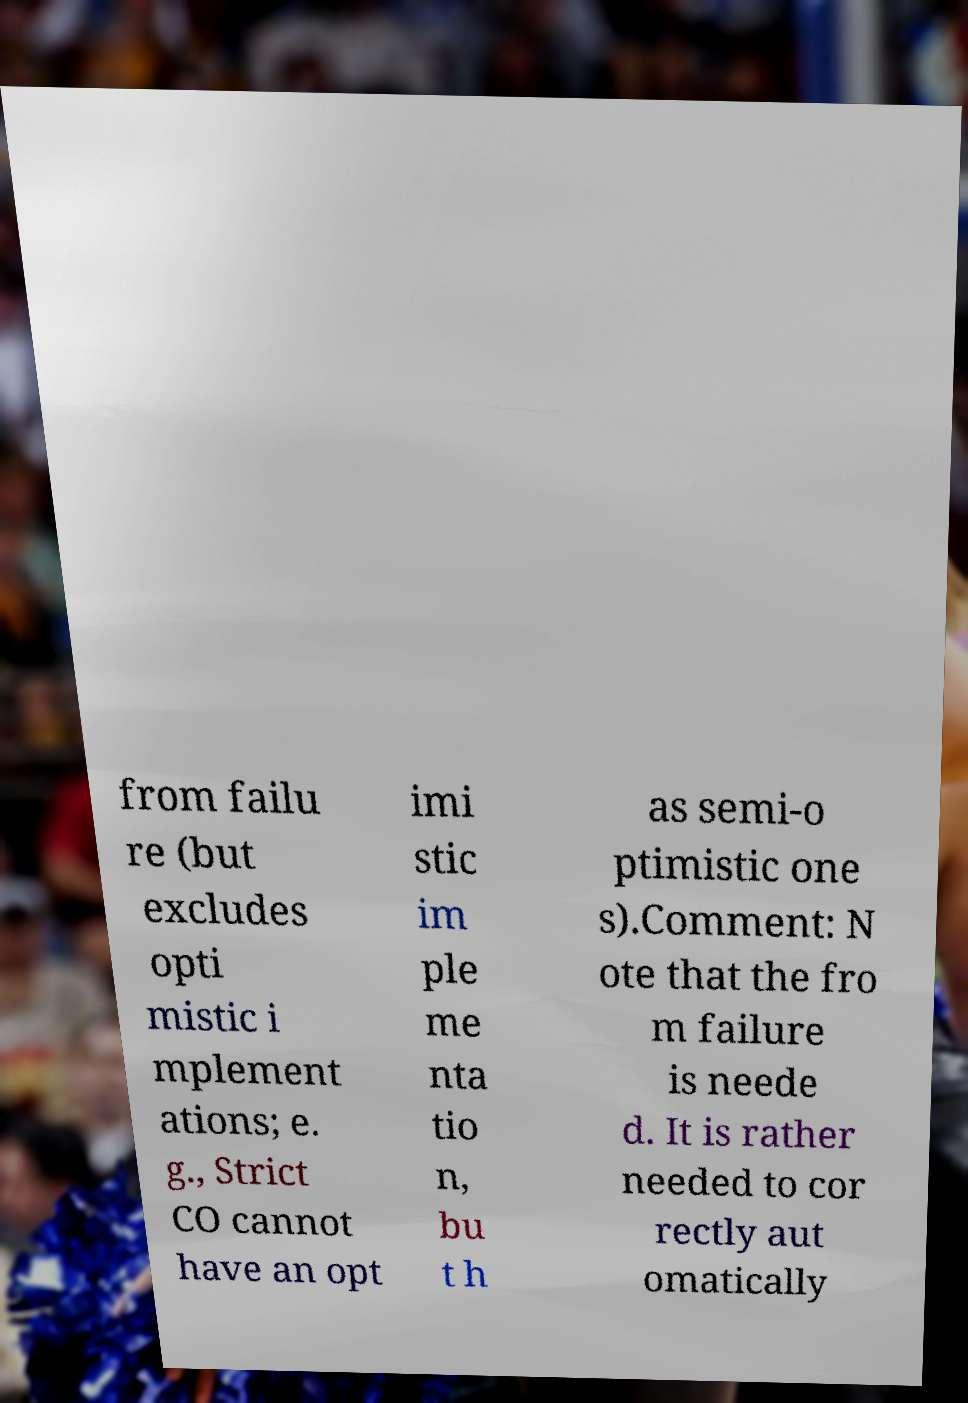Can you accurately transcribe the text from the provided image for me? from failu re (but excludes opti mistic i mplement ations; e. g., Strict CO cannot have an opt imi stic im ple me nta tio n, bu t h as semi-o ptimistic one s).Comment: N ote that the fro m failure is neede d. It is rather needed to cor rectly aut omatically 